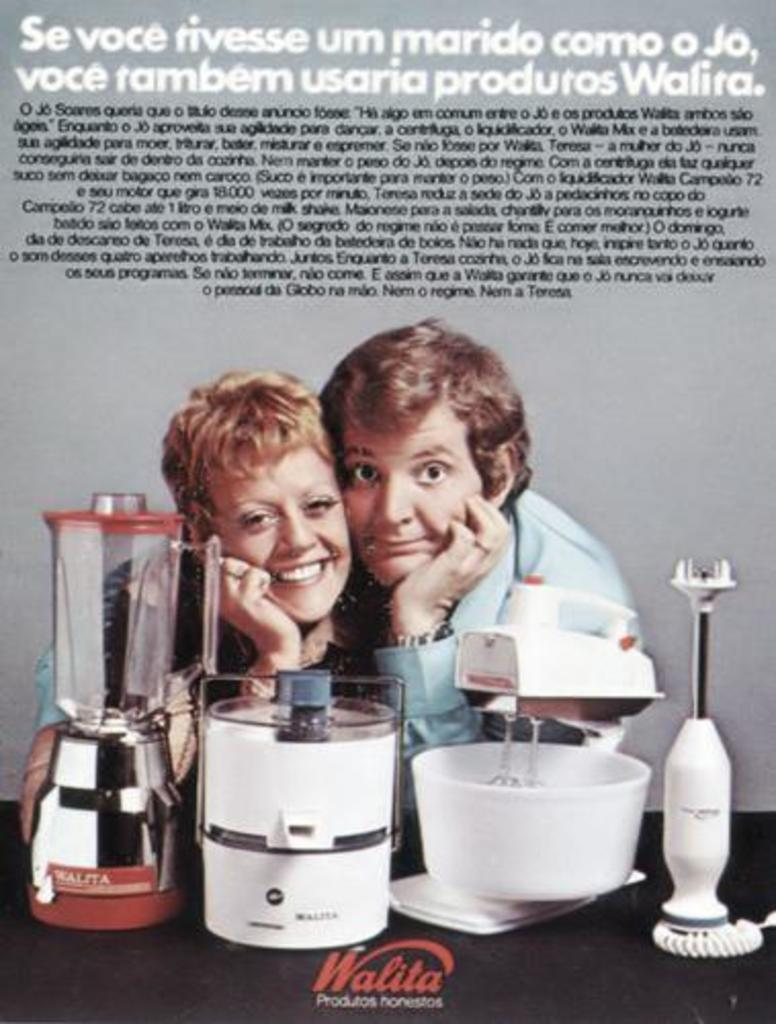Provide a one-sentence caption for the provided image. Walita logo in red for a blender, cake mixer, and food mixer. 